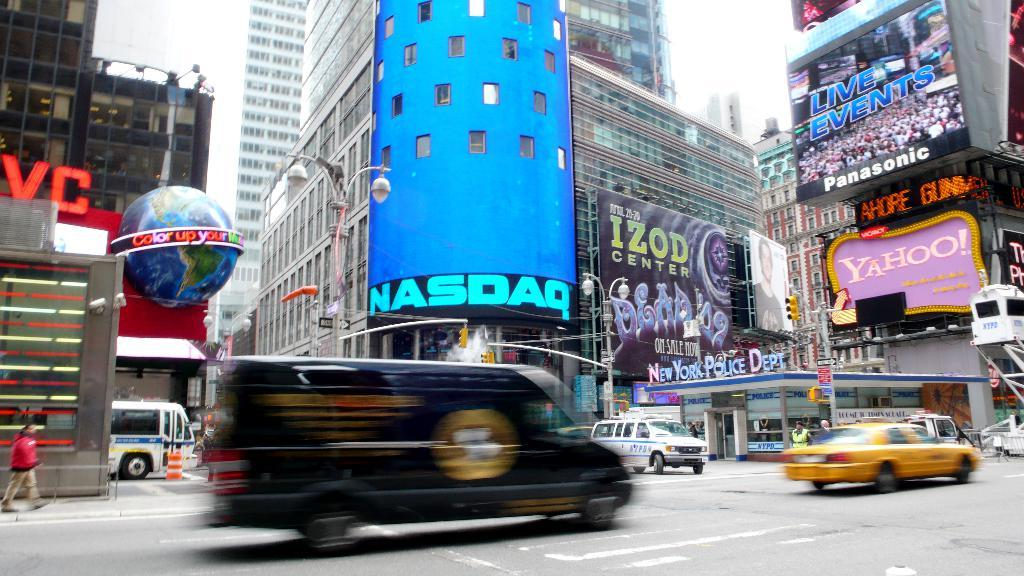<image>
Share a concise interpretation of the image provided. a lot of traffic with a NASDAQ sign around 